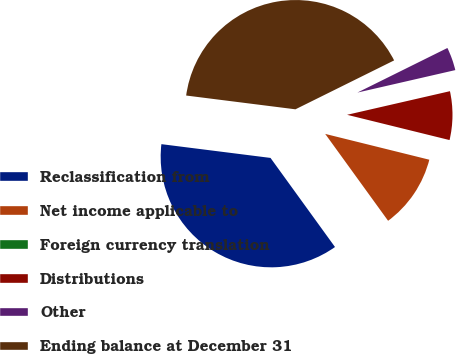Convert chart to OTSL. <chart><loc_0><loc_0><loc_500><loc_500><pie_chart><fcel>Reclassification from<fcel>Net income applicable to<fcel>Foreign currency translation<fcel>Distributions<fcel>Other<fcel>Ending balance at December 31<nl><fcel>36.97%<fcel>11.16%<fcel>0.02%<fcel>7.44%<fcel>3.73%<fcel>40.68%<nl></chart> 